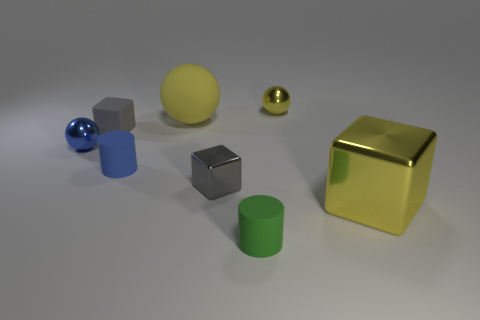Subtract all big yellow blocks. How many blocks are left? 2 Add 1 tiny yellow metallic things. How many objects exist? 9 Subtract 1 blocks. How many blocks are left? 2 Subtract all balls. How many objects are left? 5 Add 5 balls. How many balls are left? 8 Add 6 yellow spheres. How many yellow spheres exist? 8 Subtract 1 yellow balls. How many objects are left? 7 Subtract all big red cylinders. Subtract all large yellow matte spheres. How many objects are left? 7 